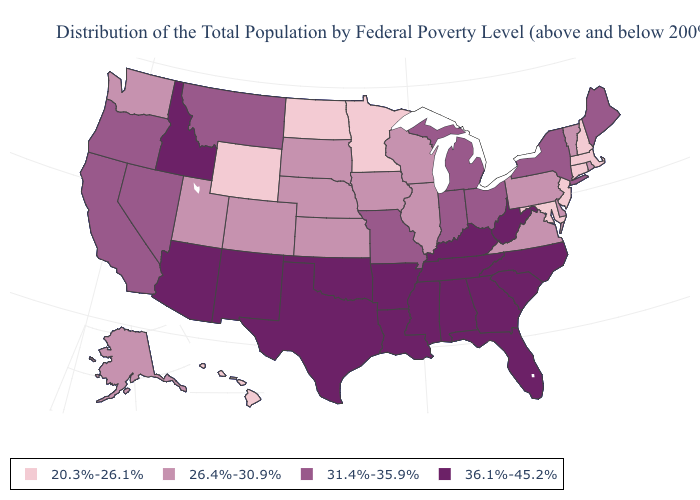Which states have the highest value in the USA?
Answer briefly. Alabama, Arizona, Arkansas, Florida, Georgia, Idaho, Kentucky, Louisiana, Mississippi, New Mexico, North Carolina, Oklahoma, South Carolina, Tennessee, Texas, West Virginia. What is the value of Delaware?
Be succinct. 26.4%-30.9%. Does Alabama have the lowest value in the USA?
Concise answer only. No. Name the states that have a value in the range 31.4%-35.9%?
Answer briefly. California, Indiana, Maine, Michigan, Missouri, Montana, Nevada, New York, Ohio, Oregon. How many symbols are there in the legend?
Short answer required. 4. Does Wisconsin have the same value as Nebraska?
Answer briefly. Yes. Which states have the lowest value in the USA?
Write a very short answer. Connecticut, Hawaii, Maryland, Massachusetts, Minnesota, New Hampshire, New Jersey, North Dakota, Wyoming. Among the states that border Oregon , which have the highest value?
Quick response, please. Idaho. What is the lowest value in the USA?
Short answer required. 20.3%-26.1%. How many symbols are there in the legend?
Answer briefly. 4. Does New Jersey have the highest value in the USA?
Quick response, please. No. Name the states that have a value in the range 31.4%-35.9%?
Write a very short answer. California, Indiana, Maine, Michigan, Missouri, Montana, Nevada, New York, Ohio, Oregon. Does New Jersey have the lowest value in the Northeast?
Write a very short answer. Yes. Name the states that have a value in the range 26.4%-30.9%?
Short answer required. Alaska, Colorado, Delaware, Illinois, Iowa, Kansas, Nebraska, Pennsylvania, Rhode Island, South Dakota, Utah, Vermont, Virginia, Washington, Wisconsin. Does New Jersey have the lowest value in the Northeast?
Keep it brief. Yes. 